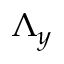Convert formula to latex. <formula><loc_0><loc_0><loc_500><loc_500>\Lambda _ { y }</formula> 